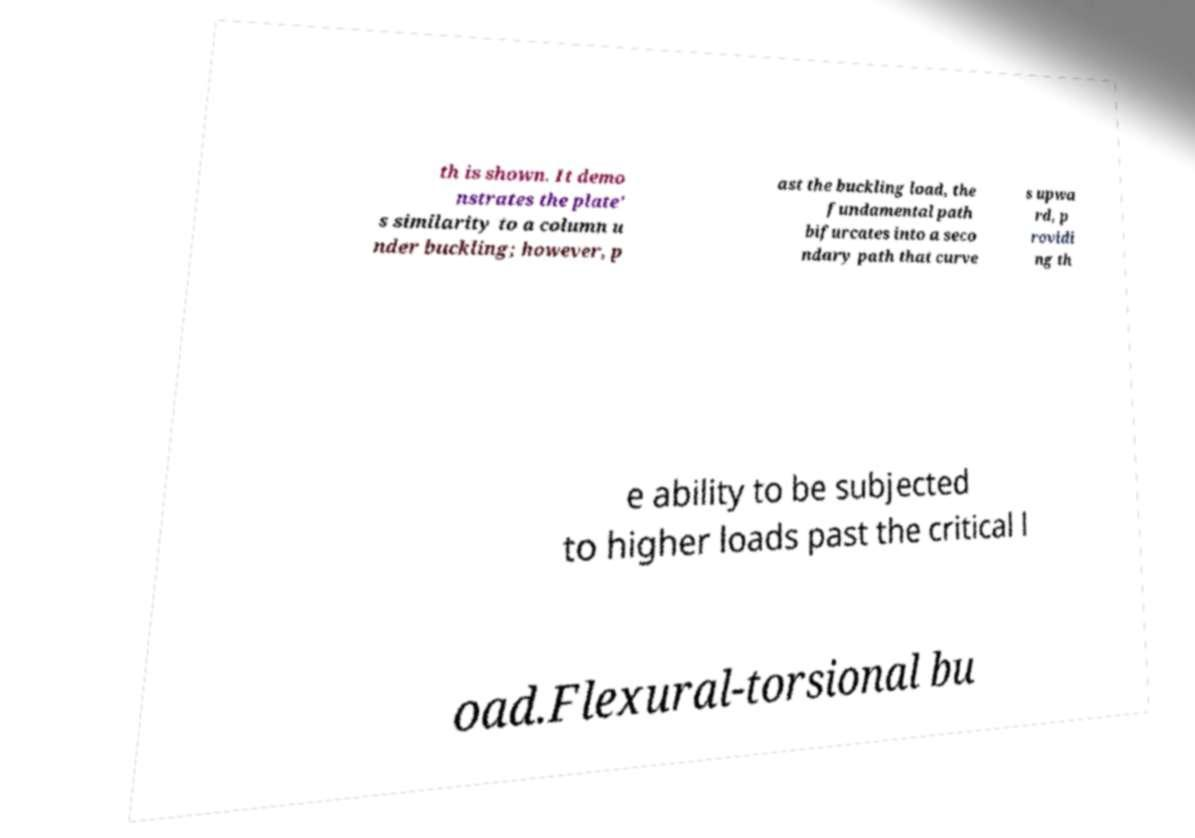Could you assist in decoding the text presented in this image and type it out clearly? th is shown. It demo nstrates the plate' s similarity to a column u nder buckling; however, p ast the buckling load, the fundamental path bifurcates into a seco ndary path that curve s upwa rd, p rovidi ng th e ability to be subjected to higher loads past the critical l oad.Flexural-torsional bu 